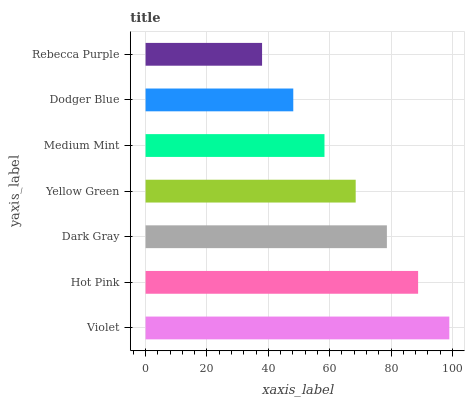Is Rebecca Purple the minimum?
Answer yes or no. Yes. Is Violet the maximum?
Answer yes or no. Yes. Is Hot Pink the minimum?
Answer yes or no. No. Is Hot Pink the maximum?
Answer yes or no. No. Is Violet greater than Hot Pink?
Answer yes or no. Yes. Is Hot Pink less than Violet?
Answer yes or no. Yes. Is Hot Pink greater than Violet?
Answer yes or no. No. Is Violet less than Hot Pink?
Answer yes or no. No. Is Yellow Green the high median?
Answer yes or no. Yes. Is Yellow Green the low median?
Answer yes or no. Yes. Is Violet the high median?
Answer yes or no. No. Is Medium Mint the low median?
Answer yes or no. No. 